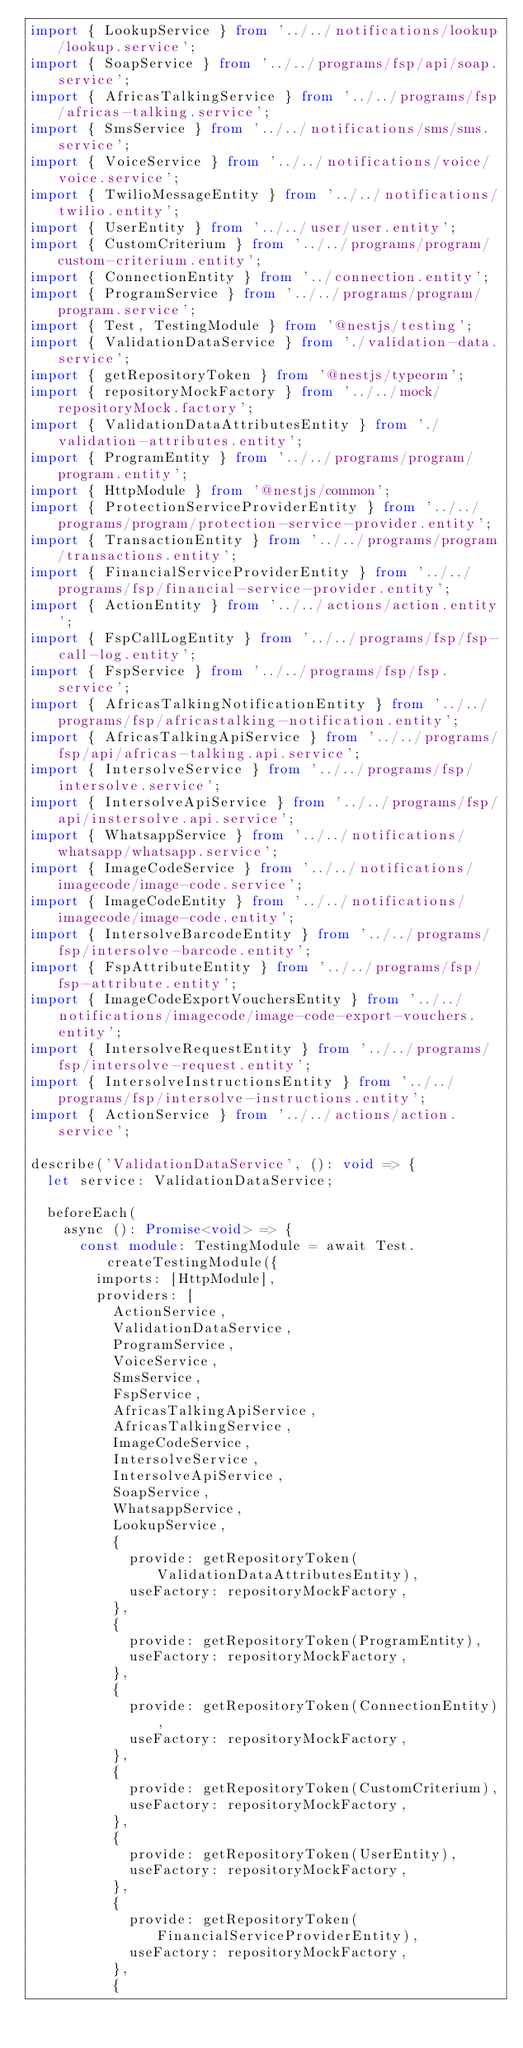<code> <loc_0><loc_0><loc_500><loc_500><_TypeScript_>import { LookupService } from '../../notifications/lookup/lookup.service';
import { SoapService } from '../../programs/fsp/api/soap.service';
import { AfricasTalkingService } from '../../programs/fsp/africas-talking.service';
import { SmsService } from '../../notifications/sms/sms.service';
import { VoiceService } from '../../notifications/voice/voice.service';
import { TwilioMessageEntity } from '../../notifications/twilio.entity';
import { UserEntity } from '../../user/user.entity';
import { CustomCriterium } from '../../programs/program/custom-criterium.entity';
import { ConnectionEntity } from '../connection.entity';
import { ProgramService } from '../../programs/program/program.service';
import { Test, TestingModule } from '@nestjs/testing';
import { ValidationDataService } from './validation-data.service';
import { getRepositoryToken } from '@nestjs/typeorm';
import { repositoryMockFactory } from '../../mock/repositoryMock.factory';
import { ValidationDataAttributesEntity } from './validation-attributes.entity';
import { ProgramEntity } from '../../programs/program/program.entity';
import { HttpModule } from '@nestjs/common';
import { ProtectionServiceProviderEntity } from '../../programs/program/protection-service-provider.entity';
import { TransactionEntity } from '../../programs/program/transactions.entity';
import { FinancialServiceProviderEntity } from '../../programs/fsp/financial-service-provider.entity';
import { ActionEntity } from '../../actions/action.entity';
import { FspCallLogEntity } from '../../programs/fsp/fsp-call-log.entity';
import { FspService } from '../../programs/fsp/fsp.service';
import { AfricasTalkingNotificationEntity } from '../../programs/fsp/africastalking-notification.entity';
import { AfricasTalkingApiService } from '../../programs/fsp/api/africas-talking.api.service';
import { IntersolveService } from '../../programs/fsp/intersolve.service';
import { IntersolveApiService } from '../../programs/fsp/api/instersolve.api.service';
import { WhatsappService } from '../../notifications/whatsapp/whatsapp.service';
import { ImageCodeService } from '../../notifications/imagecode/image-code.service';
import { ImageCodeEntity } from '../../notifications/imagecode/image-code.entity';
import { IntersolveBarcodeEntity } from '../../programs/fsp/intersolve-barcode.entity';
import { FspAttributeEntity } from '../../programs/fsp/fsp-attribute.entity';
import { ImageCodeExportVouchersEntity } from '../../notifications/imagecode/image-code-export-vouchers.entity';
import { IntersolveRequestEntity } from '../../programs/fsp/intersolve-request.entity';
import { IntersolveInstructionsEntity } from '../../programs/fsp/intersolve-instructions.entity';
import { ActionService } from '../../actions/action.service';

describe('ValidationDataService', (): void => {
  let service: ValidationDataService;

  beforeEach(
    async (): Promise<void> => {
      const module: TestingModule = await Test.createTestingModule({
        imports: [HttpModule],
        providers: [
          ActionService,
          ValidationDataService,
          ProgramService,
          VoiceService,
          SmsService,
          FspService,
          AfricasTalkingApiService,
          AfricasTalkingService,
          ImageCodeService,
          IntersolveService,
          IntersolveApiService,
          SoapService,
          WhatsappService,
          LookupService,
          {
            provide: getRepositoryToken(ValidationDataAttributesEntity),
            useFactory: repositoryMockFactory,
          },
          {
            provide: getRepositoryToken(ProgramEntity),
            useFactory: repositoryMockFactory,
          },
          {
            provide: getRepositoryToken(ConnectionEntity),
            useFactory: repositoryMockFactory,
          },
          {
            provide: getRepositoryToken(CustomCriterium),
            useFactory: repositoryMockFactory,
          },
          {
            provide: getRepositoryToken(UserEntity),
            useFactory: repositoryMockFactory,
          },
          {
            provide: getRepositoryToken(FinancialServiceProviderEntity),
            useFactory: repositoryMockFactory,
          },
          {</code> 